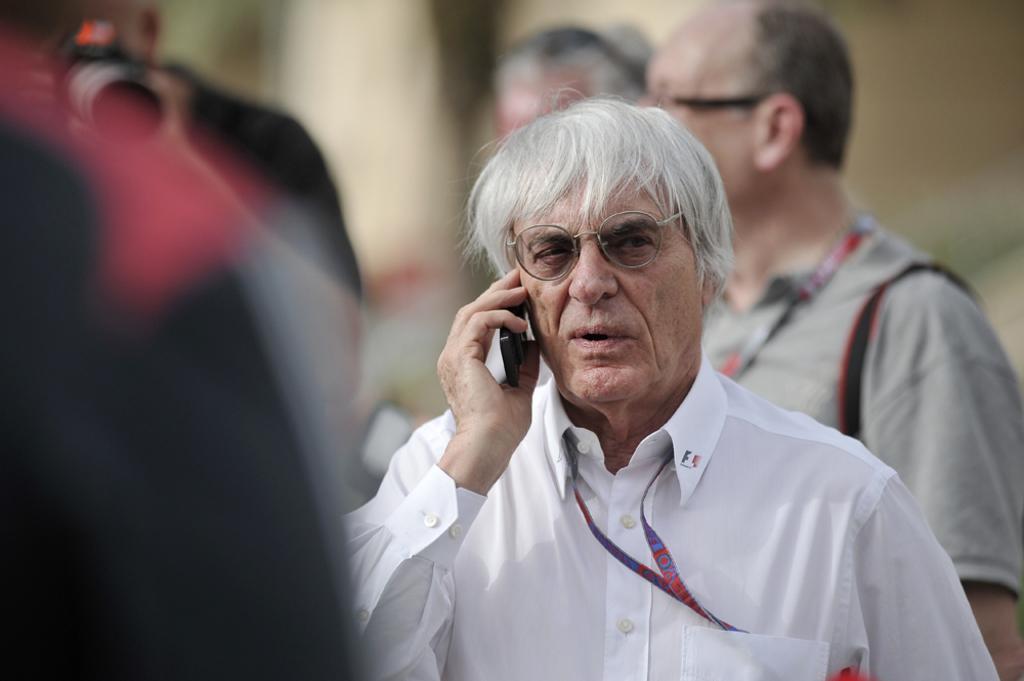In one or two sentences, can you explain what this image depicts? in this image there is one person standing in middle of this image is wearing white color dress and holding a mobile and there are some other persons in the background are standing. The person at right side is wearing spectacles and there is one object which is in black color, and there is one id card tag at bottom of this image, and there is one other person at left side of this image is holding a camera. 